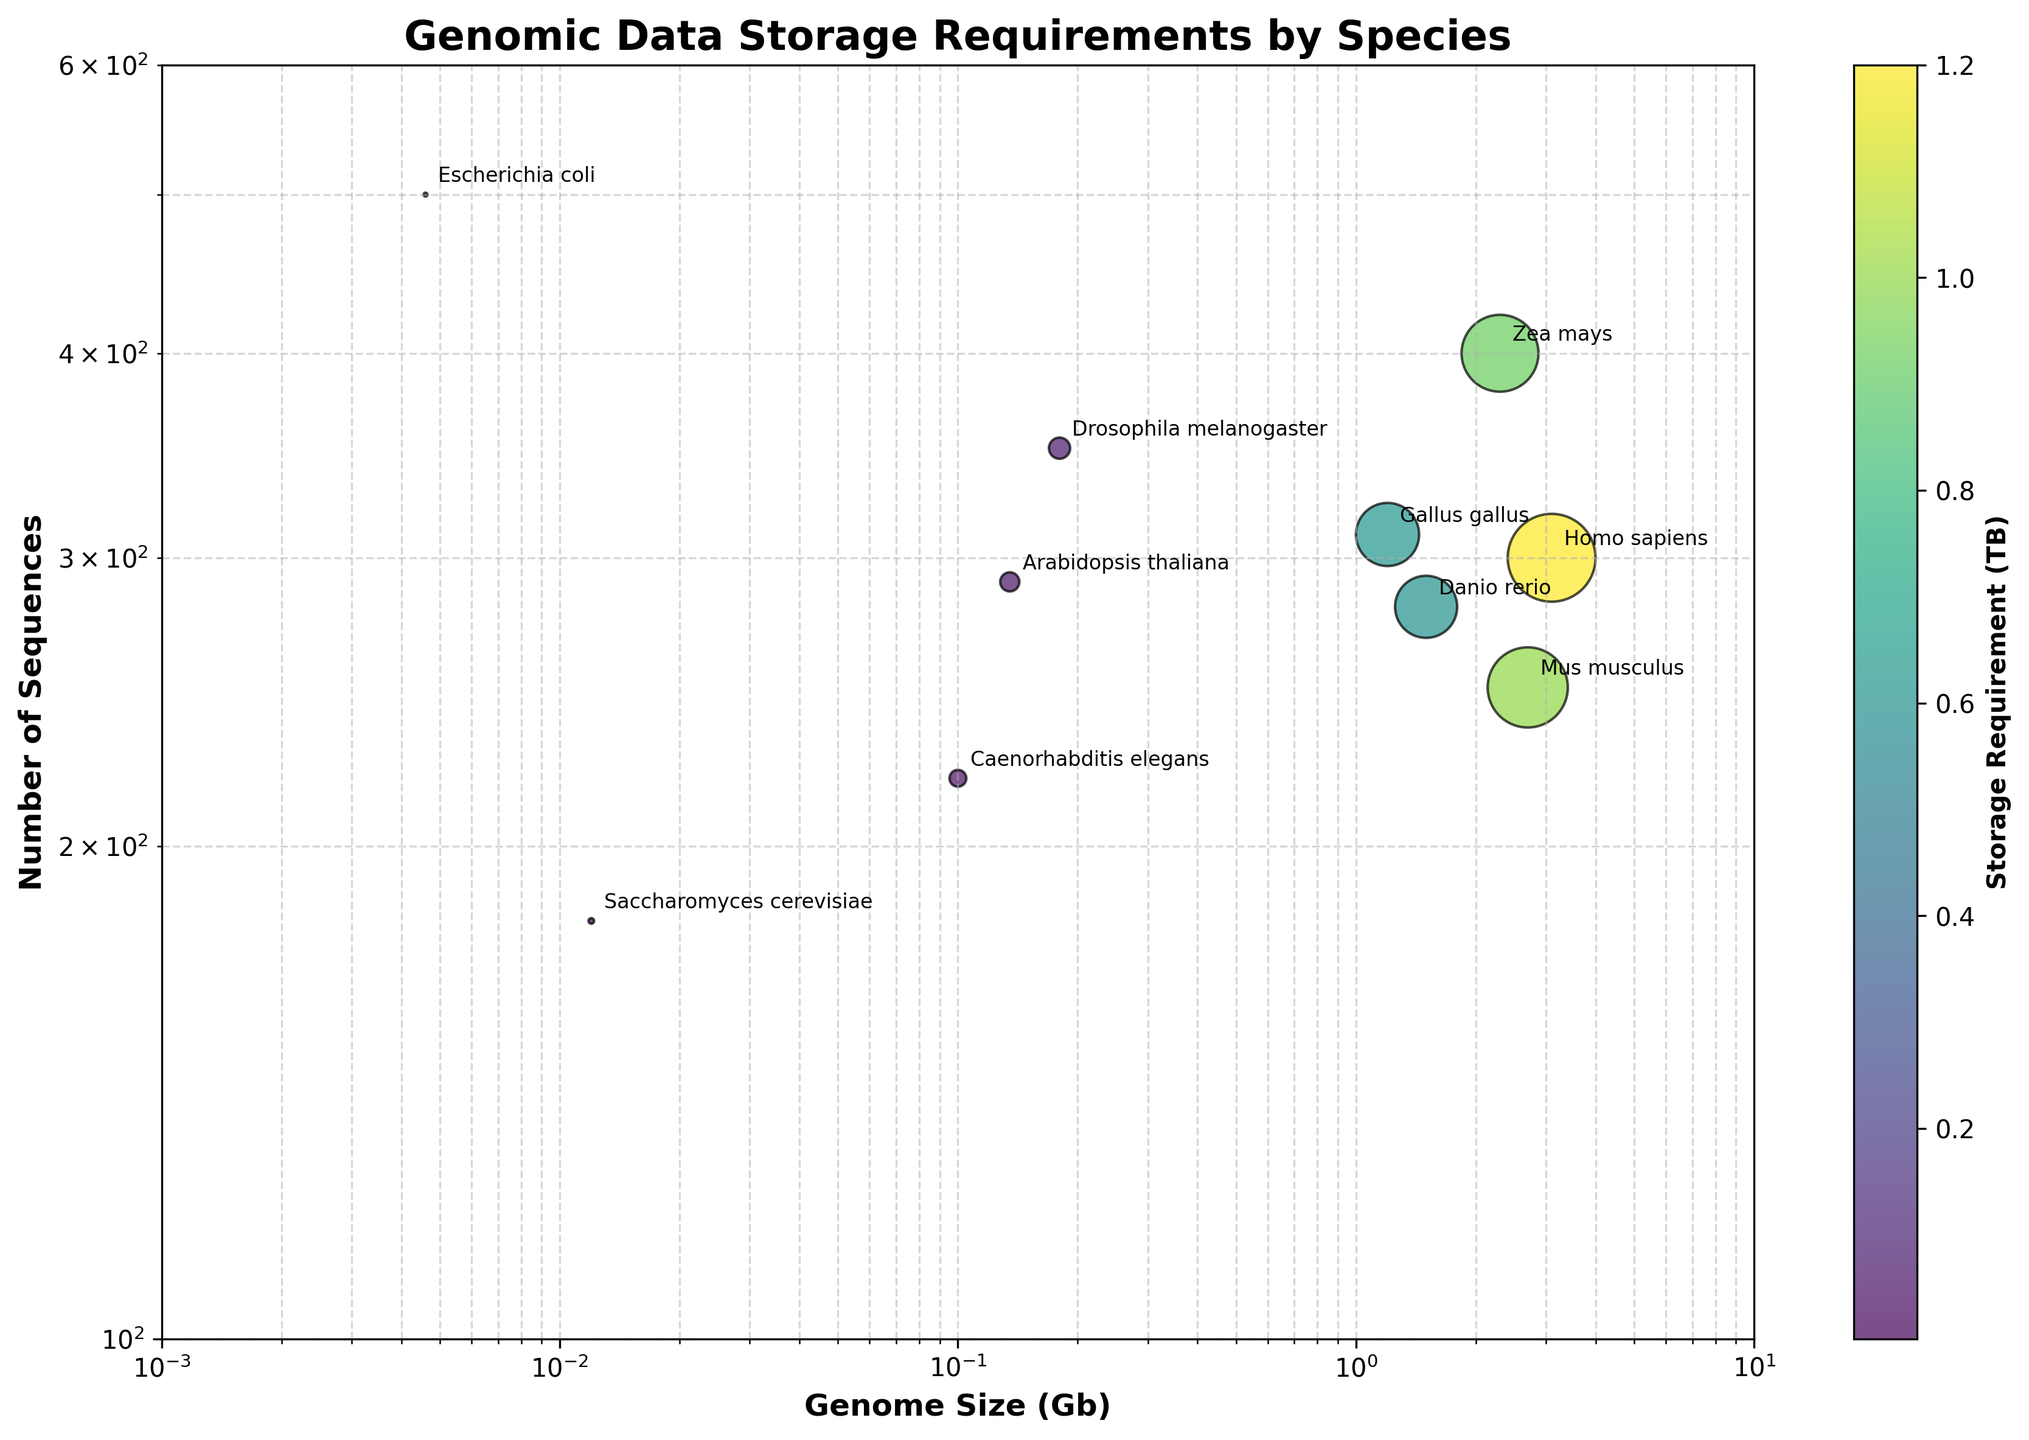what is the title of the figure? The title of the figure is located at the top of the plot and reads "Genomic Data Storage Requirements by Species".
Answer: Genomic Data Storage Requirements by Species How many species are included in the figure? The plot shows distinct bubbles representing different species. Count all labels attached to each bubble. There are 10 bubbles in total.
Answer: 10 Which species has the smallest storage requirement? Identify the smallest bubble in size and read the attached label. This species is Escherichia coli.
Answer: Escherichia coli What are the genome size and number of sequences for Homo sapiens? Locate the bubble labeled "Homo sapiens" and trace its position on the x-axis and y-axis, which correspond to genome size in Gb and number of sequences. Homo sapiens has a genome size of 3.1 Gb and 300 sequences.
Answer: 3.1 Gb and 300 sequences Which species has a storage requirement between 0.5 TB and 1 TB? Observe bubbles that fall within the color gradient between these values, then check their labels. Both Danio rerio (0.6 TB) and Gallus gallus (0.62 TB) meet this criterion.
Answer: Danio rerio and Gallus gallus Which species has more sequences, Mus musculus or Caenorhabditis elegans? Compare the y-axis values of both bubbles labeled "Mus musculus" and "Caenorhabditis elegans". Mus musculus has 250 sequences, while Caenorhabditis elegans has 220.
Answer: Mus musculus What's the ratio of the largest storage requirement to the smallest one? Identify the largest and smallest bubbles. The largest is Homo sapiens (1.2 TB) and the smallest is Escherichia coli (0.0023 TB). Compute the ratio 1.2 / 0.0023 ≈ 521.74.
Answer: 521.74 Which species has the largest genome size? Locate the bubble furthest to the right along the x-axis. This species is Homo sapiens with a genome size of 3.1 Gb.
Answer: Homo sapiens Do species with larger genome sizes tend to have higher storage requirements? Observe the trend by comparing the bubble sizes and their x-axis positions. Generally, larger genome sizes correspond to larger bubbles indicating higher storage requirements.
Answer: Yes Which species is closest to having 200 sequences? Find the bubble that is close to the y-axis value of 200. This species is Saccharomyces cerevisiae with 180 sequences.
Answer: Saccharomyces cerevisiae 